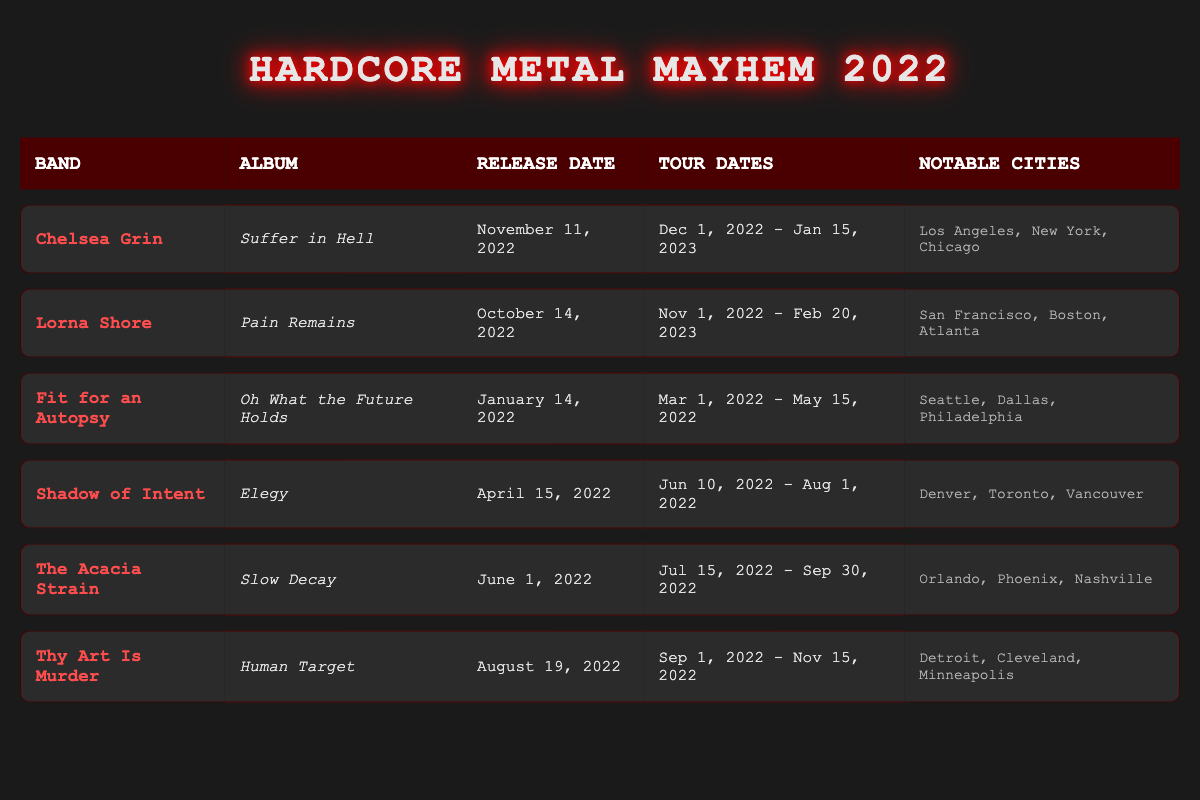What is the release date of Chelsea Grin's album? Chelsea Grin's album, "Suffer in Hell," has a listed release date of November 11, 2022. This information can be found directly in the corresponding row of the table under the "Release Date" column.
Answer: November 11, 2022 Which band released their album first in 2022? To find out which band released their album first, we need to look at the entire "Release Date" column. The earliest date is January 14, 2022, which corresponds to Fit for an Autopsy's album "Oh What the Future Holds."
Answer: Fit for an Autopsy How many notable tour cities are listed for Lorna Shore? Lorna Shore has three notable tour cities mentioned in the table: San Francisco, Boston, and Atlanta. This can be counted directly from the "Notable Cities" column.
Answer: 3 Is Shadow of Intent's album titled "Elegy"? The album for Shadow of Intent is indeed titled "Elegy," as clearly stated in the album title column for this band. Therefore, the statement is true.
Answer: Yes What is the duration of Thy Art Is Murder's tour in months? Thy Art Is Murder's tour starts on September 1, 2022, and ends on November 15, 2022. To calculate the duration, we determine the months involved: September, October, and part of November = 2.5 months. Thus, the duration is 2.5 months.
Answer: 2.5 months Which band has notable tour cities that include Minneapolis? The band with notable tour cities that include Minneapolis is Thy Art Is Murder. This can be confirmed by checking their row in the table under the "Notable Cities" column.
Answer: Thy Art Is Murder How many bands released their albums after April 2022? Four bands released their albums after April 2022. By checking the release dates of the entries, we see that Chelsea Grin, Lorna Shore, Thy Art Is Murder, and The Acacia Strain all fall into this category.
Answer: 4 What is the latest album release date among the listed bands? The latest album release date from the list is November 11, 2022, which is for Chelsea Grin's album "Suffer in Hell." This can be verified by looking for the maximum date in the "Release Date" column.
Answer: November 11, 2022 Which band toured during the summer of 2022? The bands that toured during the summer of 2022 include Shadow of Intent, The Acacia Strain, and Thy Art Is Murder. By reviewing the "Tour Dates" of each band, all these bands have parts of their tours occurring in June, July, or August.
Answer: Shadow of Intent, The Acacia Strain, Thy Art Is Murder 